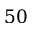Convert formula to latex. <formula><loc_0><loc_0><loc_500><loc_500>5 0</formula> 